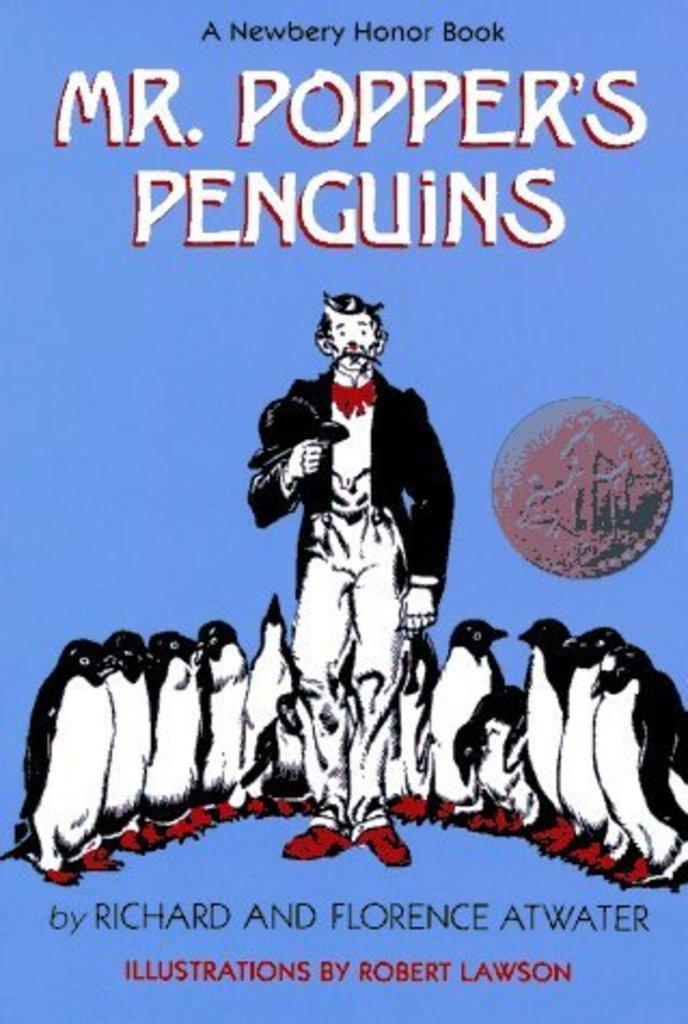<image>
Offer a succinct explanation of the picture presented. The front cover of the book "Mr. Popper's Penguins". 